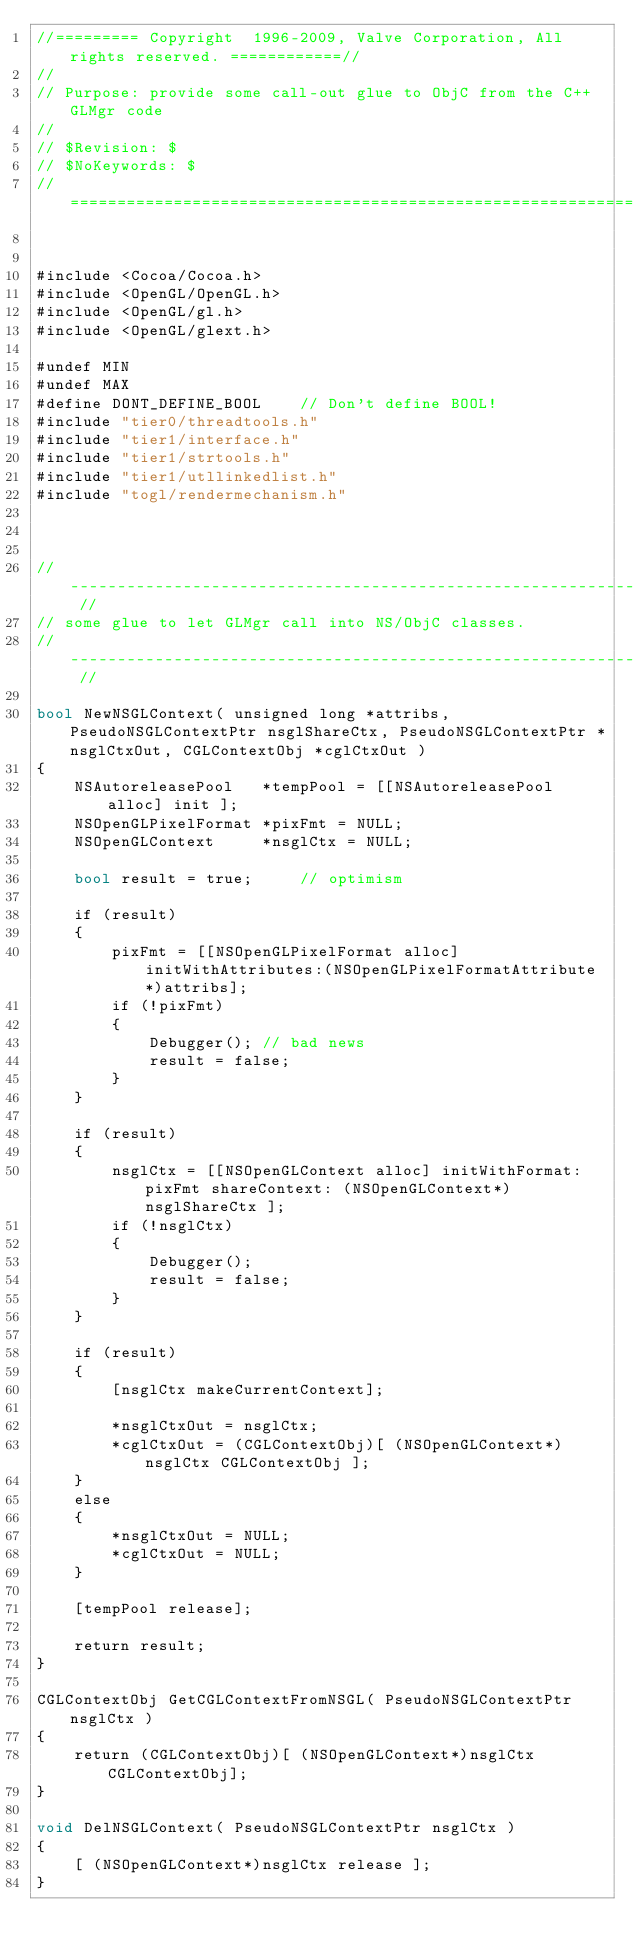<code> <loc_0><loc_0><loc_500><loc_500><_ObjectiveC_>//========= Copyright  1996-2009, Valve Corporation, All rights reserved. ============//
//
// Purpose: provide some call-out glue to ObjC from the C++ GLMgr code
//
// $Revision: $
// $NoKeywords: $
//=============================================================================//


#include <Cocoa/Cocoa.h>
#include <OpenGL/OpenGL.h>
#include <OpenGL/gl.h>
#include <OpenGL/glext.h>

#undef MIN
#undef MAX
#define DONT_DEFINE_BOOL	// Don't define BOOL!
#include "tier0/threadtools.h"
#include "tier1/interface.h"
#include "tier1/strtools.h"
#include "tier1/utllinkedlist.h"
#include "togl/rendermechanism.h"



// ------------------------------------------------------------------------------------ //
// some glue to let GLMgr call into NS/ObjC classes.
// ------------------------------------------------------------------------------------ //

bool NewNSGLContext( unsigned long *attribs, PseudoNSGLContextPtr nsglShareCtx, PseudoNSGLContextPtr *nsglCtxOut, CGLContextObj *cglCtxOut )
{
	NSAutoreleasePool	*tempPool = [[NSAutoreleasePool alloc] init ];
	NSOpenGLPixelFormat	*pixFmt = NULL; 
	NSOpenGLContext		*nsglCtx = NULL;

	bool result = true;		// optimism
	
	if (result)
	{
		pixFmt = [[NSOpenGLPixelFormat alloc] initWithAttributes:(NSOpenGLPixelFormatAttribute*)attribs];
		if (!pixFmt)
		{
			Debugger();	// bad news
			result = false;
		}
	}

	if (result)
	{
		nsglCtx = [[NSOpenGLContext alloc] initWithFormat: pixFmt shareContext: (NSOpenGLContext*) nsglShareCtx ];
		if (!nsglCtx)
		{
			Debugger();
			result = false;
		}
	}

	if (result)
	{
		[nsglCtx makeCurrentContext];
		
		*nsglCtxOut = nsglCtx;
		*cglCtxOut = (CGLContextObj)[ (NSOpenGLContext*)nsglCtx CGLContextObj ];
	}
	else
	{
		*nsglCtxOut = NULL;
		*cglCtxOut = NULL;
	}

	[tempPool release];
	
	return result;
}

CGLContextObj GetCGLContextFromNSGL( PseudoNSGLContextPtr nsglCtx )
{
	return (CGLContextObj)[ (NSOpenGLContext*)nsglCtx CGLContextObj];
}

void DelNSGLContext( PseudoNSGLContextPtr nsglCtx )
{
	[ (NSOpenGLContext*)nsglCtx release ];
}

</code> 